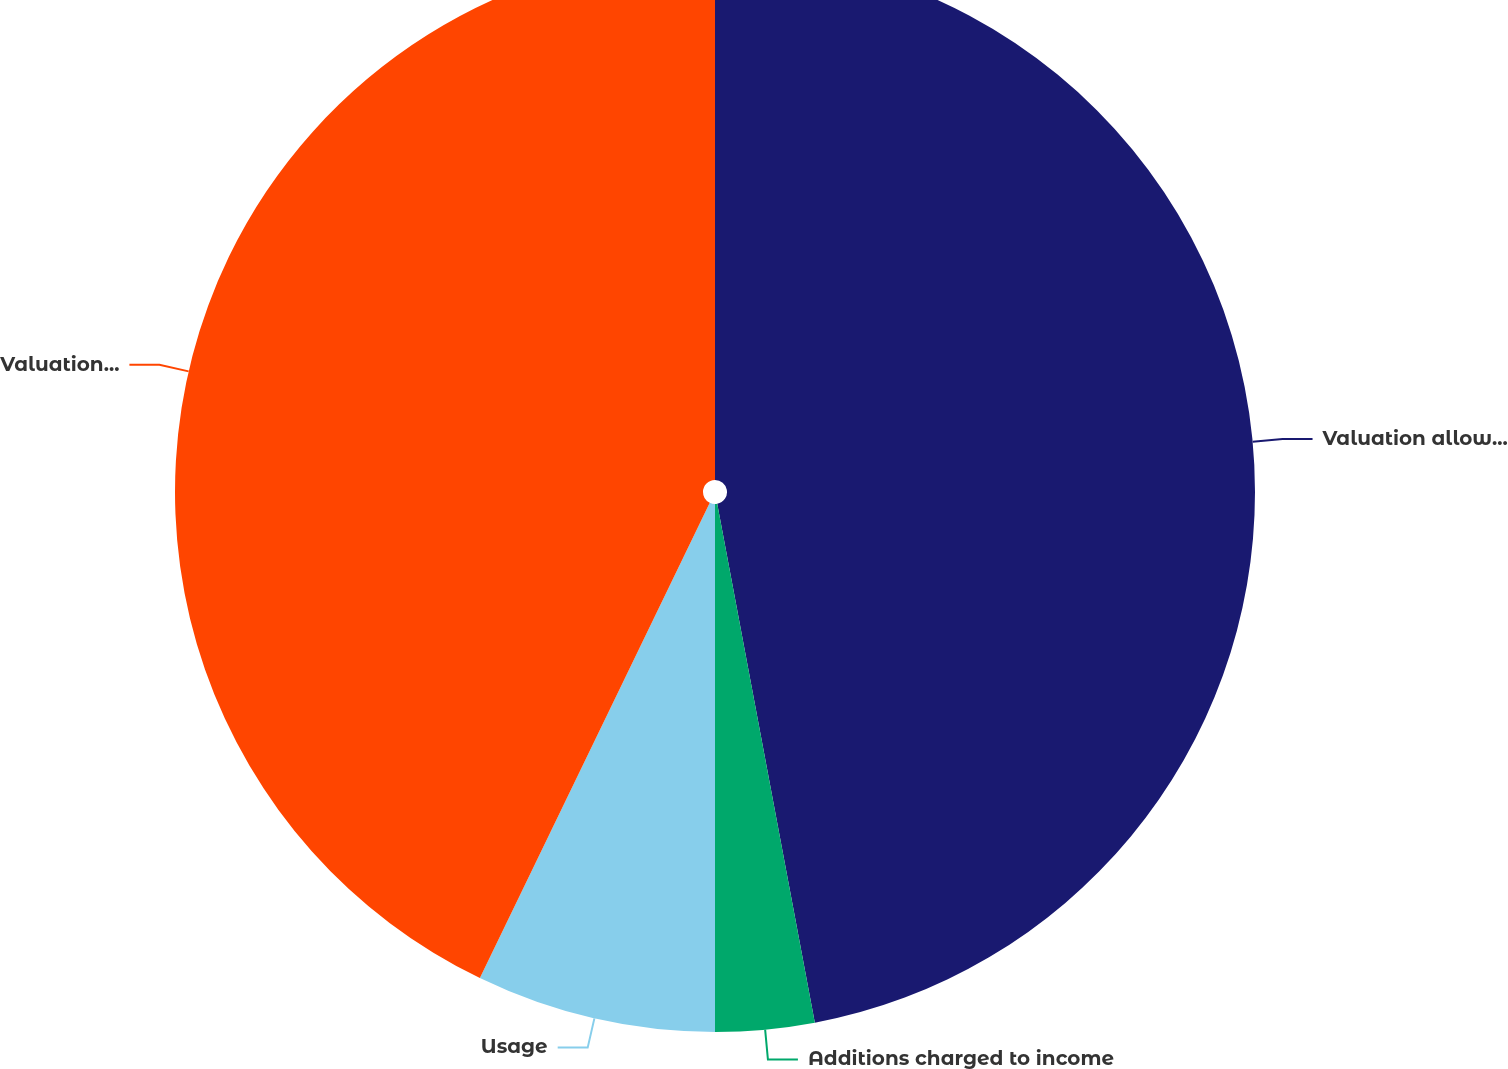Convert chart to OTSL. <chart><loc_0><loc_0><loc_500><loc_500><pie_chart><fcel>Valuation allowance beginning<fcel>Additions charged to income<fcel>Usage<fcel>Valuation allowance end of<nl><fcel>47.04%<fcel>2.96%<fcel>7.17%<fcel>42.83%<nl></chart> 